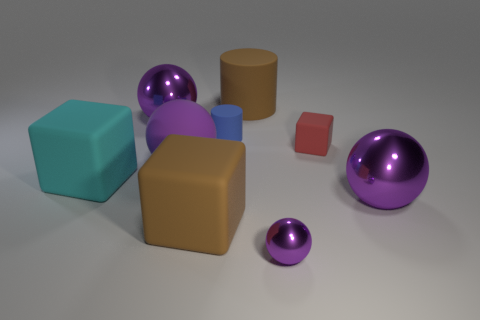Does the matte ball have the same color as the big metal thing on the right side of the brown cylinder?
Provide a short and direct response. Yes. There is a cube that is the same size as the blue matte thing; what is its material?
Provide a succinct answer. Rubber. How many things are cyan rubber blocks or metallic things that are in front of the cyan object?
Offer a very short reply. 3. There is a purple matte ball; is its size the same as the purple object that is to the right of the small red thing?
Offer a terse response. Yes. How many spheres are small blue objects or large shiny things?
Keep it short and to the point. 2. How many blocks are to the left of the blue matte cylinder and behind the big cyan rubber block?
Offer a very short reply. 0. What number of other objects are there of the same color as the large rubber sphere?
Provide a succinct answer. 3. There is a purple object that is on the left side of the purple matte object; what is its shape?
Provide a short and direct response. Sphere. Are the blue cylinder and the cyan cube made of the same material?
Your answer should be compact. Yes. There is a large brown cylinder; what number of tiny matte cylinders are behind it?
Offer a terse response. 0. 